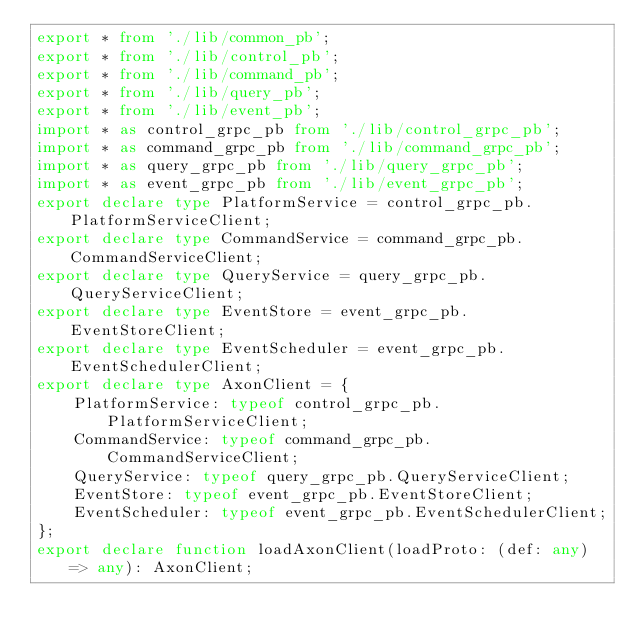Convert code to text. <code><loc_0><loc_0><loc_500><loc_500><_TypeScript_>export * from './lib/common_pb';
export * from './lib/control_pb';
export * from './lib/command_pb';
export * from './lib/query_pb';
export * from './lib/event_pb';
import * as control_grpc_pb from './lib/control_grpc_pb';
import * as command_grpc_pb from './lib/command_grpc_pb';
import * as query_grpc_pb from './lib/query_grpc_pb';
import * as event_grpc_pb from './lib/event_grpc_pb';
export declare type PlatformService = control_grpc_pb.PlatformServiceClient;
export declare type CommandService = command_grpc_pb.CommandServiceClient;
export declare type QueryService = query_grpc_pb.QueryServiceClient;
export declare type EventStore = event_grpc_pb.EventStoreClient;
export declare type EventScheduler = event_grpc_pb.EventSchedulerClient;
export declare type AxonClient = {
    PlatformService: typeof control_grpc_pb.PlatformServiceClient;
    CommandService: typeof command_grpc_pb.CommandServiceClient;
    QueryService: typeof query_grpc_pb.QueryServiceClient;
    EventStore: typeof event_grpc_pb.EventStoreClient;
    EventScheduler: typeof event_grpc_pb.EventSchedulerClient;
};
export declare function loadAxonClient(loadProto: (def: any) => any): AxonClient;
</code> 